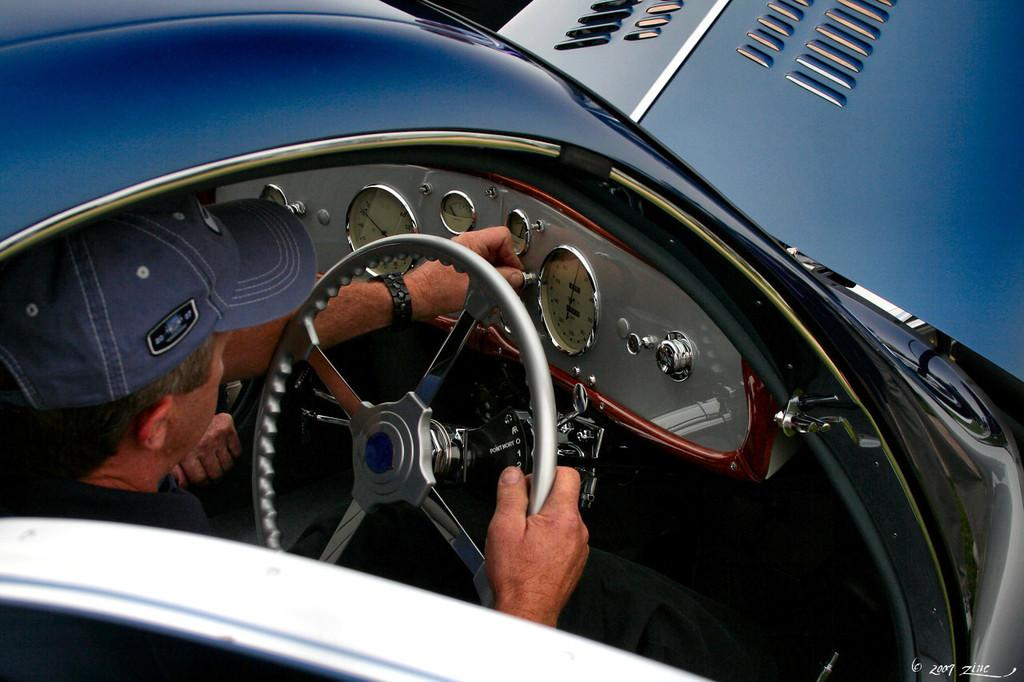Who is present in the image? There is a man in the image. What is the man doing in the image? The man is in a car and holding a steering wheel. What is the man wearing in the image? The man is wearing a blue color cap. What type of cord is the boy using to climb the roof in the image? There is no boy or roof present in the image, and therefore no such activity or cord can be observed. 